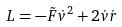Convert formula to latex. <formula><loc_0><loc_0><loc_500><loc_500>L = - \tilde { F } \dot { v } ^ { 2 } + 2 \dot { v } \dot { r }</formula> 